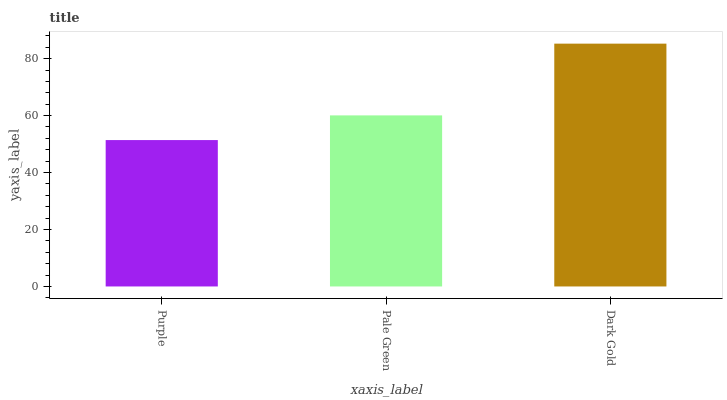Is Purple the minimum?
Answer yes or no. Yes. Is Dark Gold the maximum?
Answer yes or no. Yes. Is Pale Green the minimum?
Answer yes or no. No. Is Pale Green the maximum?
Answer yes or no. No. Is Pale Green greater than Purple?
Answer yes or no. Yes. Is Purple less than Pale Green?
Answer yes or no. Yes. Is Purple greater than Pale Green?
Answer yes or no. No. Is Pale Green less than Purple?
Answer yes or no. No. Is Pale Green the high median?
Answer yes or no. Yes. Is Pale Green the low median?
Answer yes or no. Yes. Is Dark Gold the high median?
Answer yes or no. No. Is Dark Gold the low median?
Answer yes or no. No. 